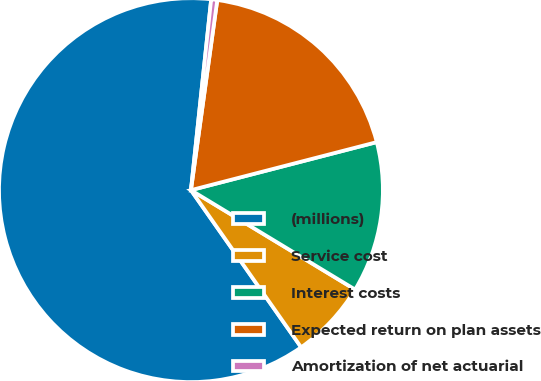Convert chart. <chart><loc_0><loc_0><loc_500><loc_500><pie_chart><fcel>(millions)<fcel>Service cost<fcel>Interest costs<fcel>Expected return on plan assets<fcel>Amortization of net actuarial<nl><fcel>61.41%<fcel>6.6%<fcel>12.69%<fcel>18.78%<fcel>0.51%<nl></chart> 